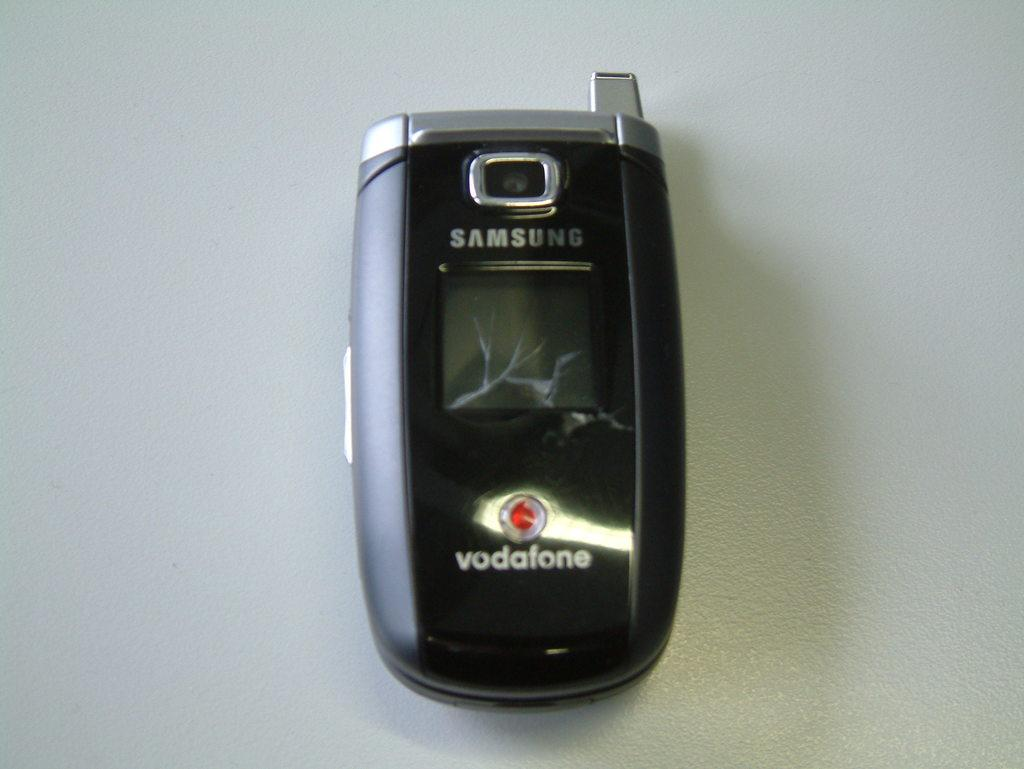<image>
Give a short and clear explanation of the subsequent image. A samsung vodafone flip phone is on a gray surface. 